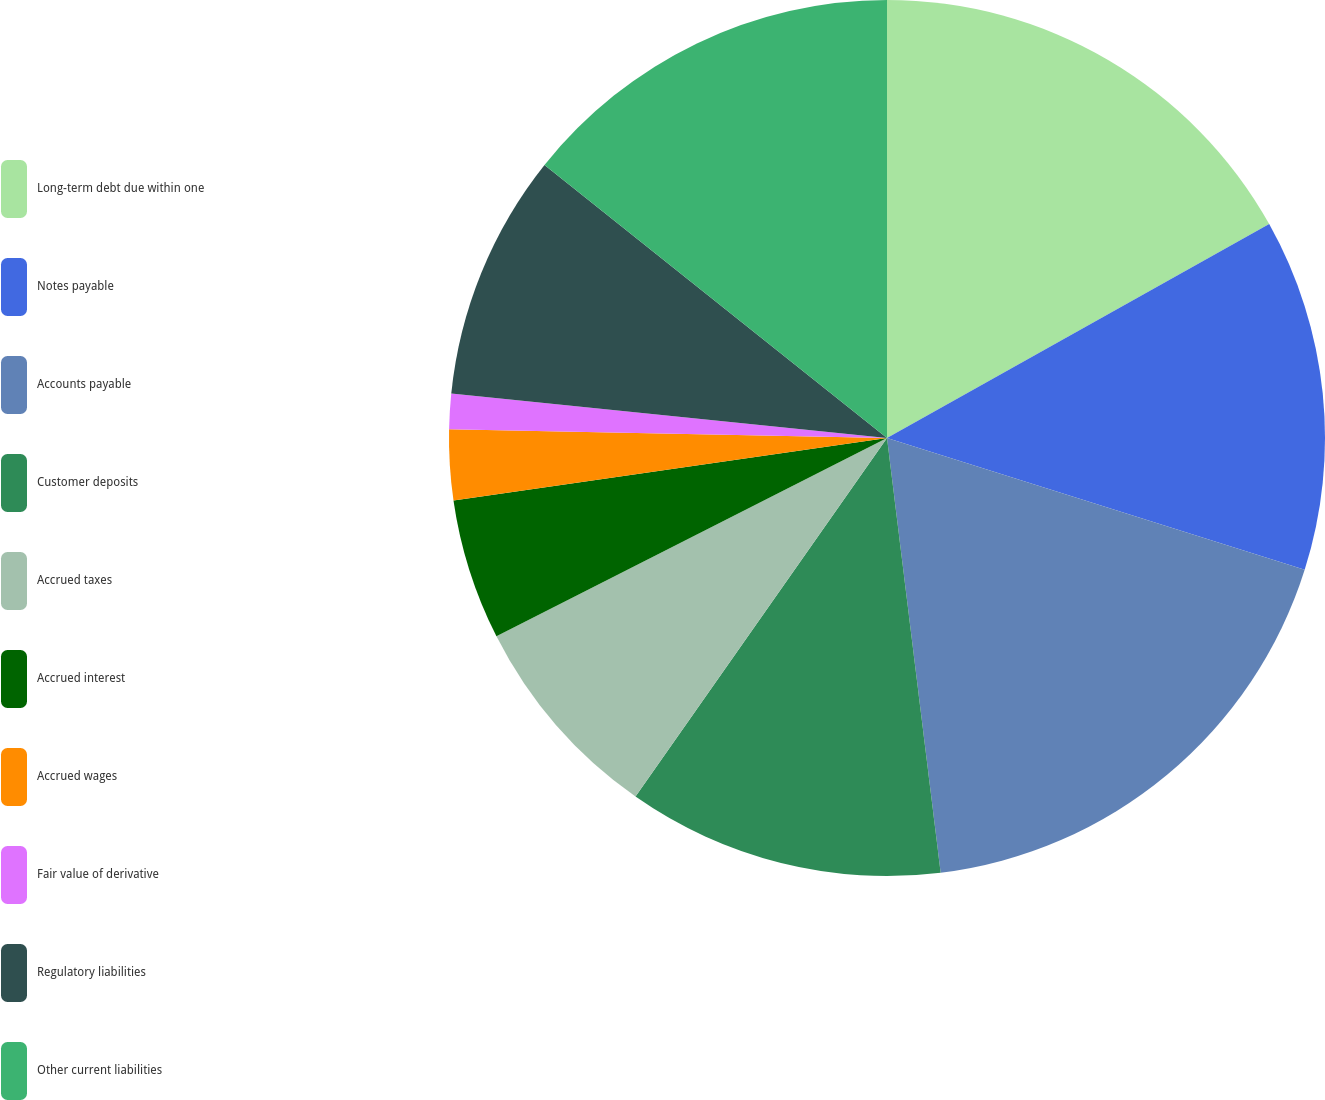Convert chart. <chart><loc_0><loc_0><loc_500><loc_500><pie_chart><fcel>Long-term debt due within one<fcel>Notes payable<fcel>Accounts payable<fcel>Customer deposits<fcel>Accrued taxes<fcel>Accrued interest<fcel>Accrued wages<fcel>Fair value of derivative<fcel>Regulatory liabilities<fcel>Other current liabilities<nl><fcel>16.88%<fcel>12.99%<fcel>18.18%<fcel>11.69%<fcel>7.79%<fcel>5.2%<fcel>2.6%<fcel>1.3%<fcel>9.09%<fcel>14.29%<nl></chart> 